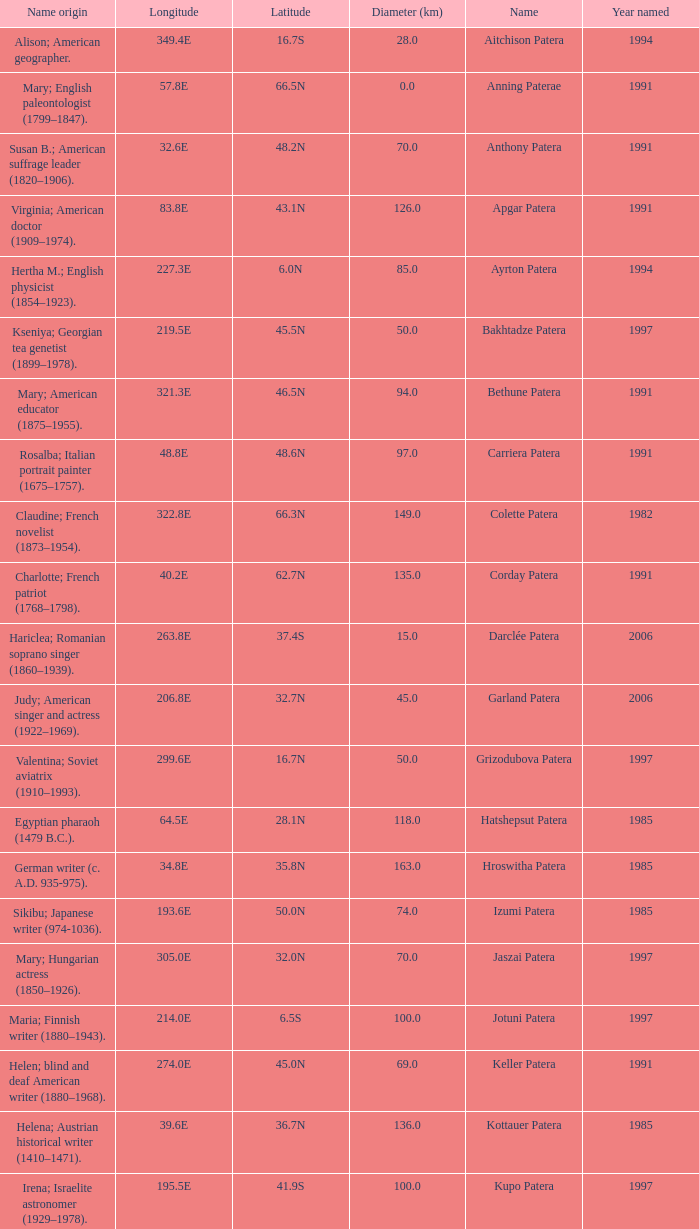What is the origin of the name of Keller Patera?  Helen; blind and deaf American writer (1880–1968). Would you mind parsing the complete table? {'header': ['Name origin', 'Longitude', 'Latitude', 'Diameter (km)', 'Name', 'Year named'], 'rows': [['Alison; American geographer.', '349.4E', '16.7S', '28.0', 'Aitchison Patera', '1994'], ['Mary; English paleontologist (1799–1847).', '57.8E', '66.5N', '0.0', 'Anning Paterae', '1991'], ['Susan B.; American suffrage leader (1820–1906).', '32.6E', '48.2N', '70.0', 'Anthony Patera', '1991'], ['Virginia; American doctor (1909–1974).', '83.8E', '43.1N', '126.0', 'Apgar Patera', '1991'], ['Hertha M.; English physicist (1854–1923).', '227.3E', '6.0N', '85.0', 'Ayrton Patera', '1994'], ['Kseniya; Georgian tea genetist (1899–1978).', '219.5E', '45.5N', '50.0', 'Bakhtadze Patera', '1997'], ['Mary; American educator (1875–1955).', '321.3E', '46.5N', '94.0', 'Bethune Patera', '1991'], ['Rosalba; Italian portrait painter (1675–1757).', '48.8E', '48.6N', '97.0', 'Carriera Patera', '1991'], ['Claudine; French novelist (1873–1954).', '322.8E', '66.3N', '149.0', 'Colette Patera', '1982'], ['Charlotte; French patriot (1768–1798).', '40.2E', '62.7N', '135.0', 'Corday Patera', '1991'], ['Hariclea; Romanian soprano singer (1860–1939).', '263.8E', '37.4S', '15.0', 'Darclée Patera', '2006'], ['Judy; American singer and actress (1922–1969).', '206.8E', '32.7N', '45.0', 'Garland Patera', '2006'], ['Valentina; Soviet aviatrix (1910–1993).', '299.6E', '16.7N', '50.0', 'Grizodubova Patera', '1997'], ['Egyptian pharaoh (1479 B.C.).', '64.5E', '28.1N', '118.0', 'Hatshepsut Patera', '1985'], ['German writer (c. A.D. 935-975).', '34.8E', '35.8N', '163.0', 'Hroswitha Patera', '1985'], ['Sikibu; Japanese writer (974-1036).', '193.6E', '50.0N', '74.0', 'Izumi Patera', '1985'], ['Mary; Hungarian actress (1850–1926).', '305.0E', '32.0N', '70.0', 'Jaszai Patera', '1997'], ['Maria; Finnish writer (1880–1943).', '214.0E', '6.5S', '100.0', 'Jotuni Patera', '1997'], ['Helen; blind and deaf American writer (1880–1968).', '274.0E', '45.0N', '69.0', 'Keller Patera', '1991'], ['Helena; Austrian historical writer (1410–1471).', '39.6E', '36.7N', '136.0', 'Kottauer Patera', '1985'], ['Irena; Israelite astronomer (1929–1978).', '195.5E', '41.9S', '100.0', 'Kupo Patera', '1997'], ['Jeanne; French artist (1767–1840).', '224.8E', '9.2S', '75.0', 'Ledoux Patera', '1994'], ['Astrid; Swedish author (1907–2002).', '241.4E', '28.1N', '110.0', 'Lindgren Patera', '2006'], ['Ganjevi; Azeri/Persian poet (c. 1050-c. 1100).', '311.0E', '16.0N', '60.0', 'Mehseti Patera', '1997'], ['Anna; Russian clay toy sculptor (1853–1938).', '68.8E', '33.3S', '60.0', 'Mezrina Patera', '2000'], ['Hedwig; Swedish poet (1718–1763).', '266.0E', '35.0S', '140.0', 'Nordenflycht Patera', '1997'], ['Varya; Gypsy/Russian singer (1872–1911).', '309.8E', '13.0S', '50.0', 'Panina Patera', '1997'], ['Cecilia Helena; American astronomer (1900–1979).', '196.0E', '25.5S', '100.0', 'Payne-Gaposchkin Patera', '1997'], ['Powhatan Indian peacemaker (1595–1617).', '49.4E', '64.9N', '78.0', 'Pocahontas Patera', '1991'], ['Marina M.; Russian aviator (1912–1943).', '222.8E', '51.0S', '80.0', 'Raskova Paterae', '1994'], ['Queen of Delhi Sultanate (India) (1236–1240).', '197.8E', '46.2N', '157.0', 'Razia Patera', '1985'], ['Klavdiya; Soviet singer (1906–1984).', '264.5E', '6.5N', '60.0', 'Shulzhenko Patera', '1997'], ['Sarah; English actress (1755–1831).', '340.6E', '61.6N', '47.0', 'Siddons Patera', '1997'], ['Marie; English paleontologist (1880–1959).', '46.5E', '42.6N', '169.0', 'Stopes Patera', '1991'], ['Ida; American author, editor (1857–1944).', '351.5E', '58.2S', '80.0', 'Tarbell Patera', '1994'], ['Sara; American poet (1884–1933).', '189.1E', '67.6S', '75.0', 'Teasdale Patera', '1994'], ['Josephine; Scottish author (1897–1952).', '349.1E', '17.8S', '20.0', 'Tey Patera', '1994'], ['Hebrew medical scholar (1500 B.C.).', '43.0E', '38.9N', '99.0', 'Tipporah Patera', '1985'], ['Allie; Canadian astronomer (1894–1988).', '194.3E', '11.6S', '45.0', 'Vibert-Douglas Patera', '2003'], ['Jeannette; French marine biologist (1794–1871).', '210.0E', '22.0S', '100.0', 'Villepreux-Power Patera', '1997'], ['Lady Jane Francesca; Irish poet (1821–1891).', '266.3E', '21.3S', '75.0', 'Wilde Patera', '2000'], ['Wilhelmine; German astronomer (1777–1854).', '247.65E', '25.8S', '35.0', 'Witte Patera', '2006'], ['Victoria; American-English lecturer (1838–1927).', '305.4E', '37.4N', '83.0', 'Woodhull Patera', '1991']]} 